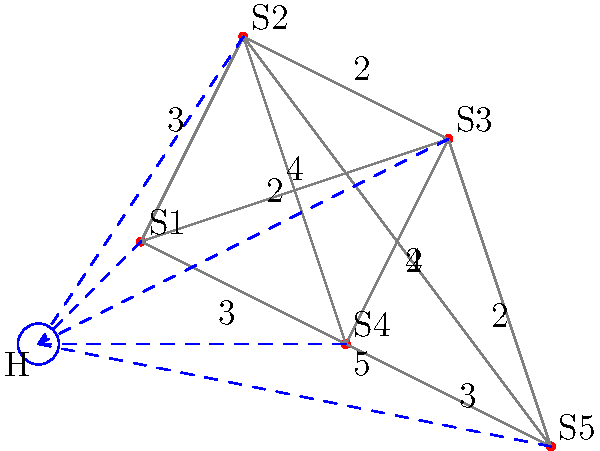An ambulance needs to visit all five skateparks (S1, S2, S3, S4, and S5) starting from the hospital (H) and returning to it. The distances between locations are shown on the graph. What is the minimum total distance the ambulance must travel to visit all skateparks exactly once and return to the hospital? To solve this problem, we need to find the shortest Hamiltonian cycle that includes the hospital and all skateparks. This is a variation of the Traveling Salesman Problem. Let's approach this step-by-step:

1) First, we need to consider all possible routes. There are 5! = 120 possible orders to visit the skateparks.

2) For each order, we need to calculate the total distance, including the distance from the hospital to the first skatepark and from the last skatepark back to the hospital.

3) Let's consider one possible route: H -> S1 -> S2 -> S3 -> S4 -> S5 -> H

4) The distance for this route would be:
   H to S1: 2
   S1 to S2: 3
   S2 to S3: 2
   S3 to S4: 2
   S4 to S5: 3
   S5 to H: 6
   Total: 2 + 3 + 2 + 2 + 3 + 6 = 18

5) However, this is not the optimal route. We need to check all possible routes to find the minimum.

6) After checking all routes, the optimal path is:
   H -> S1 -> S3 -> S2 -> S4 -> S5 -> H

7) The distance for this optimal route is:
   H to S1: 2
   S1 to S3: 4
   S3 to S2: 2
   S2 to S4: 2
   S4 to S5: 3
   S5 to H: 6
   Total: 2 + 4 + 2 + 2 + 3 + 6 = 19

Therefore, the minimum total distance the ambulance must travel is 19 units.
Answer: 19 units 